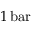Convert formula to latex. <formula><loc_0><loc_0><loc_500><loc_500>1 \, b a r</formula> 